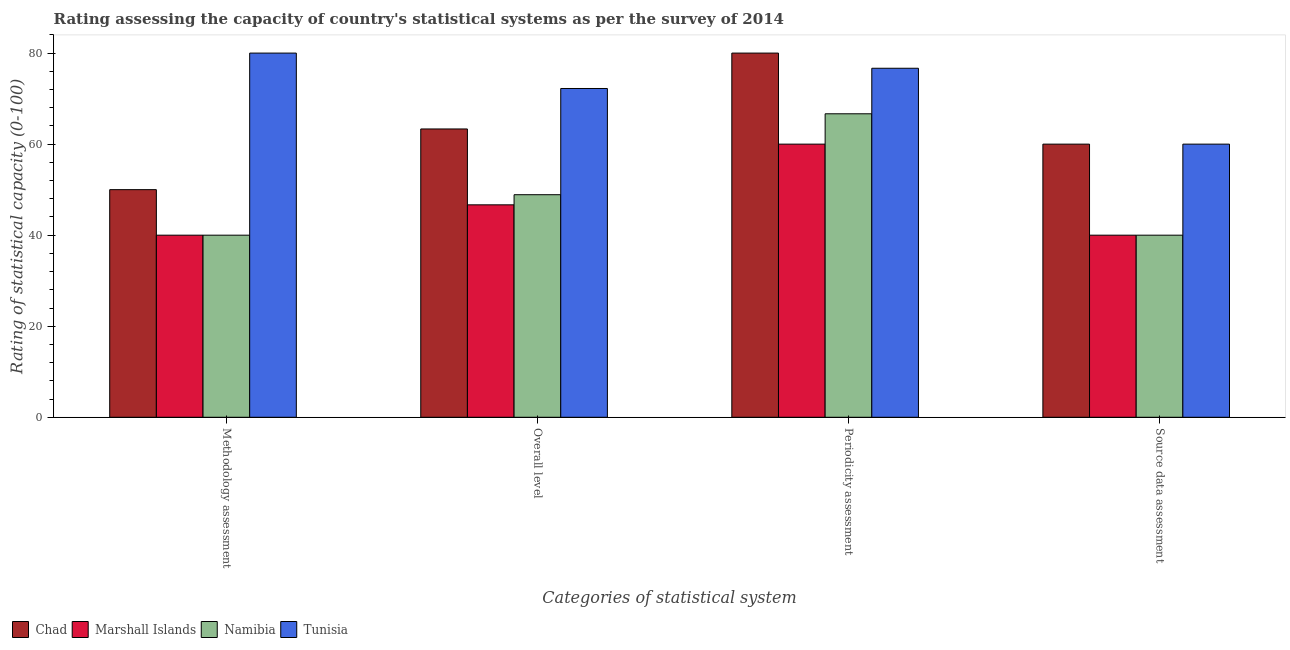How many groups of bars are there?
Keep it short and to the point. 4. Are the number of bars on each tick of the X-axis equal?
Ensure brevity in your answer.  Yes. How many bars are there on the 3rd tick from the right?
Ensure brevity in your answer.  4. What is the label of the 4th group of bars from the left?
Provide a short and direct response. Source data assessment. What is the periodicity assessment rating in Tunisia?
Provide a succinct answer. 76.67. Across all countries, what is the minimum methodology assessment rating?
Provide a succinct answer. 40. In which country was the methodology assessment rating maximum?
Keep it short and to the point. Tunisia. In which country was the periodicity assessment rating minimum?
Ensure brevity in your answer.  Marshall Islands. What is the total source data assessment rating in the graph?
Offer a terse response. 200. What is the difference between the overall level rating in Tunisia and that in Chad?
Your response must be concise. 8.89. What is the difference between the source data assessment rating in Marshall Islands and the methodology assessment rating in Chad?
Your answer should be compact. -10. What is the difference between the periodicity assessment rating and methodology assessment rating in Tunisia?
Your response must be concise. -3.33. In how many countries, is the overall level rating greater than 8 ?
Your answer should be very brief. 4. What is the ratio of the periodicity assessment rating in Namibia to that in Chad?
Give a very brief answer. 0.83. Is the difference between the source data assessment rating in Marshall Islands and Chad greater than the difference between the methodology assessment rating in Marshall Islands and Chad?
Your answer should be very brief. No. What is the difference between the highest and the second highest overall level rating?
Your response must be concise. 8.89. What is the difference between the highest and the lowest methodology assessment rating?
Make the answer very short. 40. In how many countries, is the methodology assessment rating greater than the average methodology assessment rating taken over all countries?
Your response must be concise. 1. Is the sum of the methodology assessment rating in Tunisia and Marshall Islands greater than the maximum overall level rating across all countries?
Give a very brief answer. Yes. Is it the case that in every country, the sum of the source data assessment rating and methodology assessment rating is greater than the sum of periodicity assessment rating and overall level rating?
Keep it short and to the point. No. What does the 2nd bar from the left in Source data assessment represents?
Your response must be concise. Marshall Islands. What does the 4th bar from the right in Overall level represents?
Offer a terse response. Chad. How many bars are there?
Make the answer very short. 16. Are all the bars in the graph horizontal?
Ensure brevity in your answer.  No. Does the graph contain any zero values?
Your answer should be compact. No. Does the graph contain grids?
Offer a very short reply. No. How many legend labels are there?
Ensure brevity in your answer.  4. What is the title of the graph?
Keep it short and to the point. Rating assessing the capacity of country's statistical systems as per the survey of 2014 . What is the label or title of the X-axis?
Your answer should be very brief. Categories of statistical system. What is the label or title of the Y-axis?
Your response must be concise. Rating of statistical capacity (0-100). What is the Rating of statistical capacity (0-100) in Marshall Islands in Methodology assessment?
Offer a very short reply. 40. What is the Rating of statistical capacity (0-100) in Tunisia in Methodology assessment?
Your response must be concise. 80. What is the Rating of statistical capacity (0-100) of Chad in Overall level?
Keep it short and to the point. 63.33. What is the Rating of statistical capacity (0-100) in Marshall Islands in Overall level?
Keep it short and to the point. 46.67. What is the Rating of statistical capacity (0-100) in Namibia in Overall level?
Your answer should be compact. 48.89. What is the Rating of statistical capacity (0-100) in Tunisia in Overall level?
Ensure brevity in your answer.  72.22. What is the Rating of statistical capacity (0-100) of Chad in Periodicity assessment?
Offer a very short reply. 80. What is the Rating of statistical capacity (0-100) of Marshall Islands in Periodicity assessment?
Provide a short and direct response. 60. What is the Rating of statistical capacity (0-100) in Namibia in Periodicity assessment?
Your answer should be very brief. 66.67. What is the Rating of statistical capacity (0-100) in Tunisia in Periodicity assessment?
Offer a terse response. 76.67. What is the Rating of statistical capacity (0-100) in Marshall Islands in Source data assessment?
Your answer should be compact. 40. What is the Rating of statistical capacity (0-100) of Namibia in Source data assessment?
Provide a short and direct response. 40. What is the Rating of statistical capacity (0-100) in Tunisia in Source data assessment?
Keep it short and to the point. 60. Across all Categories of statistical system, what is the maximum Rating of statistical capacity (0-100) in Chad?
Provide a succinct answer. 80. Across all Categories of statistical system, what is the maximum Rating of statistical capacity (0-100) of Marshall Islands?
Provide a succinct answer. 60. Across all Categories of statistical system, what is the maximum Rating of statistical capacity (0-100) in Namibia?
Your answer should be compact. 66.67. Across all Categories of statistical system, what is the maximum Rating of statistical capacity (0-100) of Tunisia?
Your response must be concise. 80. What is the total Rating of statistical capacity (0-100) in Chad in the graph?
Provide a short and direct response. 253.33. What is the total Rating of statistical capacity (0-100) in Marshall Islands in the graph?
Provide a short and direct response. 186.67. What is the total Rating of statistical capacity (0-100) in Namibia in the graph?
Offer a terse response. 195.56. What is the total Rating of statistical capacity (0-100) of Tunisia in the graph?
Offer a very short reply. 288.89. What is the difference between the Rating of statistical capacity (0-100) in Chad in Methodology assessment and that in Overall level?
Your answer should be very brief. -13.33. What is the difference between the Rating of statistical capacity (0-100) of Marshall Islands in Methodology assessment and that in Overall level?
Give a very brief answer. -6.67. What is the difference between the Rating of statistical capacity (0-100) of Namibia in Methodology assessment and that in Overall level?
Your answer should be compact. -8.89. What is the difference between the Rating of statistical capacity (0-100) of Tunisia in Methodology assessment and that in Overall level?
Provide a succinct answer. 7.78. What is the difference between the Rating of statistical capacity (0-100) of Chad in Methodology assessment and that in Periodicity assessment?
Provide a succinct answer. -30. What is the difference between the Rating of statistical capacity (0-100) in Marshall Islands in Methodology assessment and that in Periodicity assessment?
Offer a very short reply. -20. What is the difference between the Rating of statistical capacity (0-100) of Namibia in Methodology assessment and that in Periodicity assessment?
Make the answer very short. -26.67. What is the difference between the Rating of statistical capacity (0-100) of Tunisia in Methodology assessment and that in Periodicity assessment?
Make the answer very short. 3.33. What is the difference between the Rating of statistical capacity (0-100) in Chad in Methodology assessment and that in Source data assessment?
Give a very brief answer. -10. What is the difference between the Rating of statistical capacity (0-100) in Marshall Islands in Methodology assessment and that in Source data assessment?
Your response must be concise. 0. What is the difference between the Rating of statistical capacity (0-100) of Namibia in Methodology assessment and that in Source data assessment?
Keep it short and to the point. 0. What is the difference between the Rating of statistical capacity (0-100) of Tunisia in Methodology assessment and that in Source data assessment?
Give a very brief answer. 20. What is the difference between the Rating of statistical capacity (0-100) in Chad in Overall level and that in Periodicity assessment?
Your answer should be compact. -16.67. What is the difference between the Rating of statistical capacity (0-100) of Marshall Islands in Overall level and that in Periodicity assessment?
Offer a terse response. -13.33. What is the difference between the Rating of statistical capacity (0-100) of Namibia in Overall level and that in Periodicity assessment?
Ensure brevity in your answer.  -17.78. What is the difference between the Rating of statistical capacity (0-100) of Tunisia in Overall level and that in Periodicity assessment?
Provide a succinct answer. -4.44. What is the difference between the Rating of statistical capacity (0-100) of Marshall Islands in Overall level and that in Source data assessment?
Keep it short and to the point. 6.67. What is the difference between the Rating of statistical capacity (0-100) in Namibia in Overall level and that in Source data assessment?
Keep it short and to the point. 8.89. What is the difference between the Rating of statistical capacity (0-100) in Tunisia in Overall level and that in Source data assessment?
Offer a terse response. 12.22. What is the difference between the Rating of statistical capacity (0-100) of Marshall Islands in Periodicity assessment and that in Source data assessment?
Offer a very short reply. 20. What is the difference between the Rating of statistical capacity (0-100) in Namibia in Periodicity assessment and that in Source data assessment?
Offer a terse response. 26.67. What is the difference between the Rating of statistical capacity (0-100) in Tunisia in Periodicity assessment and that in Source data assessment?
Keep it short and to the point. 16.67. What is the difference between the Rating of statistical capacity (0-100) of Chad in Methodology assessment and the Rating of statistical capacity (0-100) of Namibia in Overall level?
Your response must be concise. 1.11. What is the difference between the Rating of statistical capacity (0-100) of Chad in Methodology assessment and the Rating of statistical capacity (0-100) of Tunisia in Overall level?
Your response must be concise. -22.22. What is the difference between the Rating of statistical capacity (0-100) of Marshall Islands in Methodology assessment and the Rating of statistical capacity (0-100) of Namibia in Overall level?
Give a very brief answer. -8.89. What is the difference between the Rating of statistical capacity (0-100) in Marshall Islands in Methodology assessment and the Rating of statistical capacity (0-100) in Tunisia in Overall level?
Provide a succinct answer. -32.22. What is the difference between the Rating of statistical capacity (0-100) of Namibia in Methodology assessment and the Rating of statistical capacity (0-100) of Tunisia in Overall level?
Your answer should be compact. -32.22. What is the difference between the Rating of statistical capacity (0-100) of Chad in Methodology assessment and the Rating of statistical capacity (0-100) of Namibia in Periodicity assessment?
Your answer should be very brief. -16.67. What is the difference between the Rating of statistical capacity (0-100) of Chad in Methodology assessment and the Rating of statistical capacity (0-100) of Tunisia in Periodicity assessment?
Give a very brief answer. -26.67. What is the difference between the Rating of statistical capacity (0-100) in Marshall Islands in Methodology assessment and the Rating of statistical capacity (0-100) in Namibia in Periodicity assessment?
Keep it short and to the point. -26.67. What is the difference between the Rating of statistical capacity (0-100) of Marshall Islands in Methodology assessment and the Rating of statistical capacity (0-100) of Tunisia in Periodicity assessment?
Keep it short and to the point. -36.67. What is the difference between the Rating of statistical capacity (0-100) of Namibia in Methodology assessment and the Rating of statistical capacity (0-100) of Tunisia in Periodicity assessment?
Keep it short and to the point. -36.67. What is the difference between the Rating of statistical capacity (0-100) in Chad in Methodology assessment and the Rating of statistical capacity (0-100) in Namibia in Source data assessment?
Provide a succinct answer. 10. What is the difference between the Rating of statistical capacity (0-100) of Chad in Methodology assessment and the Rating of statistical capacity (0-100) of Tunisia in Source data assessment?
Give a very brief answer. -10. What is the difference between the Rating of statistical capacity (0-100) in Marshall Islands in Methodology assessment and the Rating of statistical capacity (0-100) in Namibia in Source data assessment?
Give a very brief answer. 0. What is the difference between the Rating of statistical capacity (0-100) of Chad in Overall level and the Rating of statistical capacity (0-100) of Namibia in Periodicity assessment?
Offer a very short reply. -3.33. What is the difference between the Rating of statistical capacity (0-100) of Chad in Overall level and the Rating of statistical capacity (0-100) of Tunisia in Periodicity assessment?
Your response must be concise. -13.33. What is the difference between the Rating of statistical capacity (0-100) of Marshall Islands in Overall level and the Rating of statistical capacity (0-100) of Tunisia in Periodicity assessment?
Provide a succinct answer. -30. What is the difference between the Rating of statistical capacity (0-100) of Namibia in Overall level and the Rating of statistical capacity (0-100) of Tunisia in Periodicity assessment?
Give a very brief answer. -27.78. What is the difference between the Rating of statistical capacity (0-100) of Chad in Overall level and the Rating of statistical capacity (0-100) of Marshall Islands in Source data assessment?
Give a very brief answer. 23.33. What is the difference between the Rating of statistical capacity (0-100) in Chad in Overall level and the Rating of statistical capacity (0-100) in Namibia in Source data assessment?
Your answer should be very brief. 23.33. What is the difference between the Rating of statistical capacity (0-100) of Marshall Islands in Overall level and the Rating of statistical capacity (0-100) of Namibia in Source data assessment?
Provide a short and direct response. 6.67. What is the difference between the Rating of statistical capacity (0-100) in Marshall Islands in Overall level and the Rating of statistical capacity (0-100) in Tunisia in Source data assessment?
Ensure brevity in your answer.  -13.33. What is the difference between the Rating of statistical capacity (0-100) in Namibia in Overall level and the Rating of statistical capacity (0-100) in Tunisia in Source data assessment?
Provide a succinct answer. -11.11. What is the difference between the Rating of statistical capacity (0-100) in Marshall Islands in Periodicity assessment and the Rating of statistical capacity (0-100) in Tunisia in Source data assessment?
Make the answer very short. 0. What is the difference between the Rating of statistical capacity (0-100) of Namibia in Periodicity assessment and the Rating of statistical capacity (0-100) of Tunisia in Source data assessment?
Make the answer very short. 6.67. What is the average Rating of statistical capacity (0-100) in Chad per Categories of statistical system?
Your answer should be compact. 63.33. What is the average Rating of statistical capacity (0-100) in Marshall Islands per Categories of statistical system?
Your answer should be compact. 46.67. What is the average Rating of statistical capacity (0-100) in Namibia per Categories of statistical system?
Ensure brevity in your answer.  48.89. What is the average Rating of statistical capacity (0-100) of Tunisia per Categories of statistical system?
Your answer should be compact. 72.22. What is the difference between the Rating of statistical capacity (0-100) in Chad and Rating of statistical capacity (0-100) in Tunisia in Methodology assessment?
Provide a succinct answer. -30. What is the difference between the Rating of statistical capacity (0-100) in Marshall Islands and Rating of statistical capacity (0-100) in Namibia in Methodology assessment?
Offer a terse response. 0. What is the difference between the Rating of statistical capacity (0-100) of Chad and Rating of statistical capacity (0-100) of Marshall Islands in Overall level?
Offer a very short reply. 16.67. What is the difference between the Rating of statistical capacity (0-100) of Chad and Rating of statistical capacity (0-100) of Namibia in Overall level?
Provide a succinct answer. 14.44. What is the difference between the Rating of statistical capacity (0-100) of Chad and Rating of statistical capacity (0-100) of Tunisia in Overall level?
Your response must be concise. -8.89. What is the difference between the Rating of statistical capacity (0-100) of Marshall Islands and Rating of statistical capacity (0-100) of Namibia in Overall level?
Your answer should be compact. -2.22. What is the difference between the Rating of statistical capacity (0-100) of Marshall Islands and Rating of statistical capacity (0-100) of Tunisia in Overall level?
Offer a very short reply. -25.56. What is the difference between the Rating of statistical capacity (0-100) of Namibia and Rating of statistical capacity (0-100) of Tunisia in Overall level?
Make the answer very short. -23.33. What is the difference between the Rating of statistical capacity (0-100) in Chad and Rating of statistical capacity (0-100) in Namibia in Periodicity assessment?
Make the answer very short. 13.33. What is the difference between the Rating of statistical capacity (0-100) in Chad and Rating of statistical capacity (0-100) in Tunisia in Periodicity assessment?
Your answer should be very brief. 3.33. What is the difference between the Rating of statistical capacity (0-100) in Marshall Islands and Rating of statistical capacity (0-100) in Namibia in Periodicity assessment?
Give a very brief answer. -6.67. What is the difference between the Rating of statistical capacity (0-100) in Marshall Islands and Rating of statistical capacity (0-100) in Tunisia in Periodicity assessment?
Your answer should be compact. -16.67. What is the difference between the Rating of statistical capacity (0-100) of Chad and Rating of statistical capacity (0-100) of Namibia in Source data assessment?
Provide a succinct answer. 20. What is the difference between the Rating of statistical capacity (0-100) of Chad and Rating of statistical capacity (0-100) of Tunisia in Source data assessment?
Offer a terse response. 0. What is the difference between the Rating of statistical capacity (0-100) in Marshall Islands and Rating of statistical capacity (0-100) in Tunisia in Source data assessment?
Your response must be concise. -20. What is the difference between the Rating of statistical capacity (0-100) of Namibia and Rating of statistical capacity (0-100) of Tunisia in Source data assessment?
Your answer should be compact. -20. What is the ratio of the Rating of statistical capacity (0-100) of Chad in Methodology assessment to that in Overall level?
Your answer should be compact. 0.79. What is the ratio of the Rating of statistical capacity (0-100) in Marshall Islands in Methodology assessment to that in Overall level?
Give a very brief answer. 0.86. What is the ratio of the Rating of statistical capacity (0-100) of Namibia in Methodology assessment to that in Overall level?
Offer a terse response. 0.82. What is the ratio of the Rating of statistical capacity (0-100) of Tunisia in Methodology assessment to that in Overall level?
Your answer should be very brief. 1.11. What is the ratio of the Rating of statistical capacity (0-100) of Chad in Methodology assessment to that in Periodicity assessment?
Provide a succinct answer. 0.62. What is the ratio of the Rating of statistical capacity (0-100) in Marshall Islands in Methodology assessment to that in Periodicity assessment?
Make the answer very short. 0.67. What is the ratio of the Rating of statistical capacity (0-100) of Namibia in Methodology assessment to that in Periodicity assessment?
Provide a succinct answer. 0.6. What is the ratio of the Rating of statistical capacity (0-100) in Tunisia in Methodology assessment to that in Periodicity assessment?
Give a very brief answer. 1.04. What is the ratio of the Rating of statistical capacity (0-100) in Tunisia in Methodology assessment to that in Source data assessment?
Ensure brevity in your answer.  1.33. What is the ratio of the Rating of statistical capacity (0-100) of Chad in Overall level to that in Periodicity assessment?
Your response must be concise. 0.79. What is the ratio of the Rating of statistical capacity (0-100) of Namibia in Overall level to that in Periodicity assessment?
Provide a succinct answer. 0.73. What is the ratio of the Rating of statistical capacity (0-100) in Tunisia in Overall level to that in Periodicity assessment?
Your answer should be compact. 0.94. What is the ratio of the Rating of statistical capacity (0-100) in Chad in Overall level to that in Source data assessment?
Provide a short and direct response. 1.06. What is the ratio of the Rating of statistical capacity (0-100) in Namibia in Overall level to that in Source data assessment?
Provide a succinct answer. 1.22. What is the ratio of the Rating of statistical capacity (0-100) of Tunisia in Overall level to that in Source data assessment?
Your response must be concise. 1.2. What is the ratio of the Rating of statistical capacity (0-100) in Chad in Periodicity assessment to that in Source data assessment?
Give a very brief answer. 1.33. What is the ratio of the Rating of statistical capacity (0-100) in Marshall Islands in Periodicity assessment to that in Source data assessment?
Ensure brevity in your answer.  1.5. What is the ratio of the Rating of statistical capacity (0-100) in Namibia in Periodicity assessment to that in Source data assessment?
Give a very brief answer. 1.67. What is the ratio of the Rating of statistical capacity (0-100) in Tunisia in Periodicity assessment to that in Source data assessment?
Offer a very short reply. 1.28. What is the difference between the highest and the second highest Rating of statistical capacity (0-100) in Chad?
Offer a very short reply. 16.67. What is the difference between the highest and the second highest Rating of statistical capacity (0-100) of Marshall Islands?
Offer a very short reply. 13.33. What is the difference between the highest and the second highest Rating of statistical capacity (0-100) of Namibia?
Offer a terse response. 17.78. What is the difference between the highest and the second highest Rating of statistical capacity (0-100) of Tunisia?
Provide a short and direct response. 3.33. What is the difference between the highest and the lowest Rating of statistical capacity (0-100) in Marshall Islands?
Keep it short and to the point. 20. What is the difference between the highest and the lowest Rating of statistical capacity (0-100) in Namibia?
Offer a terse response. 26.67. 